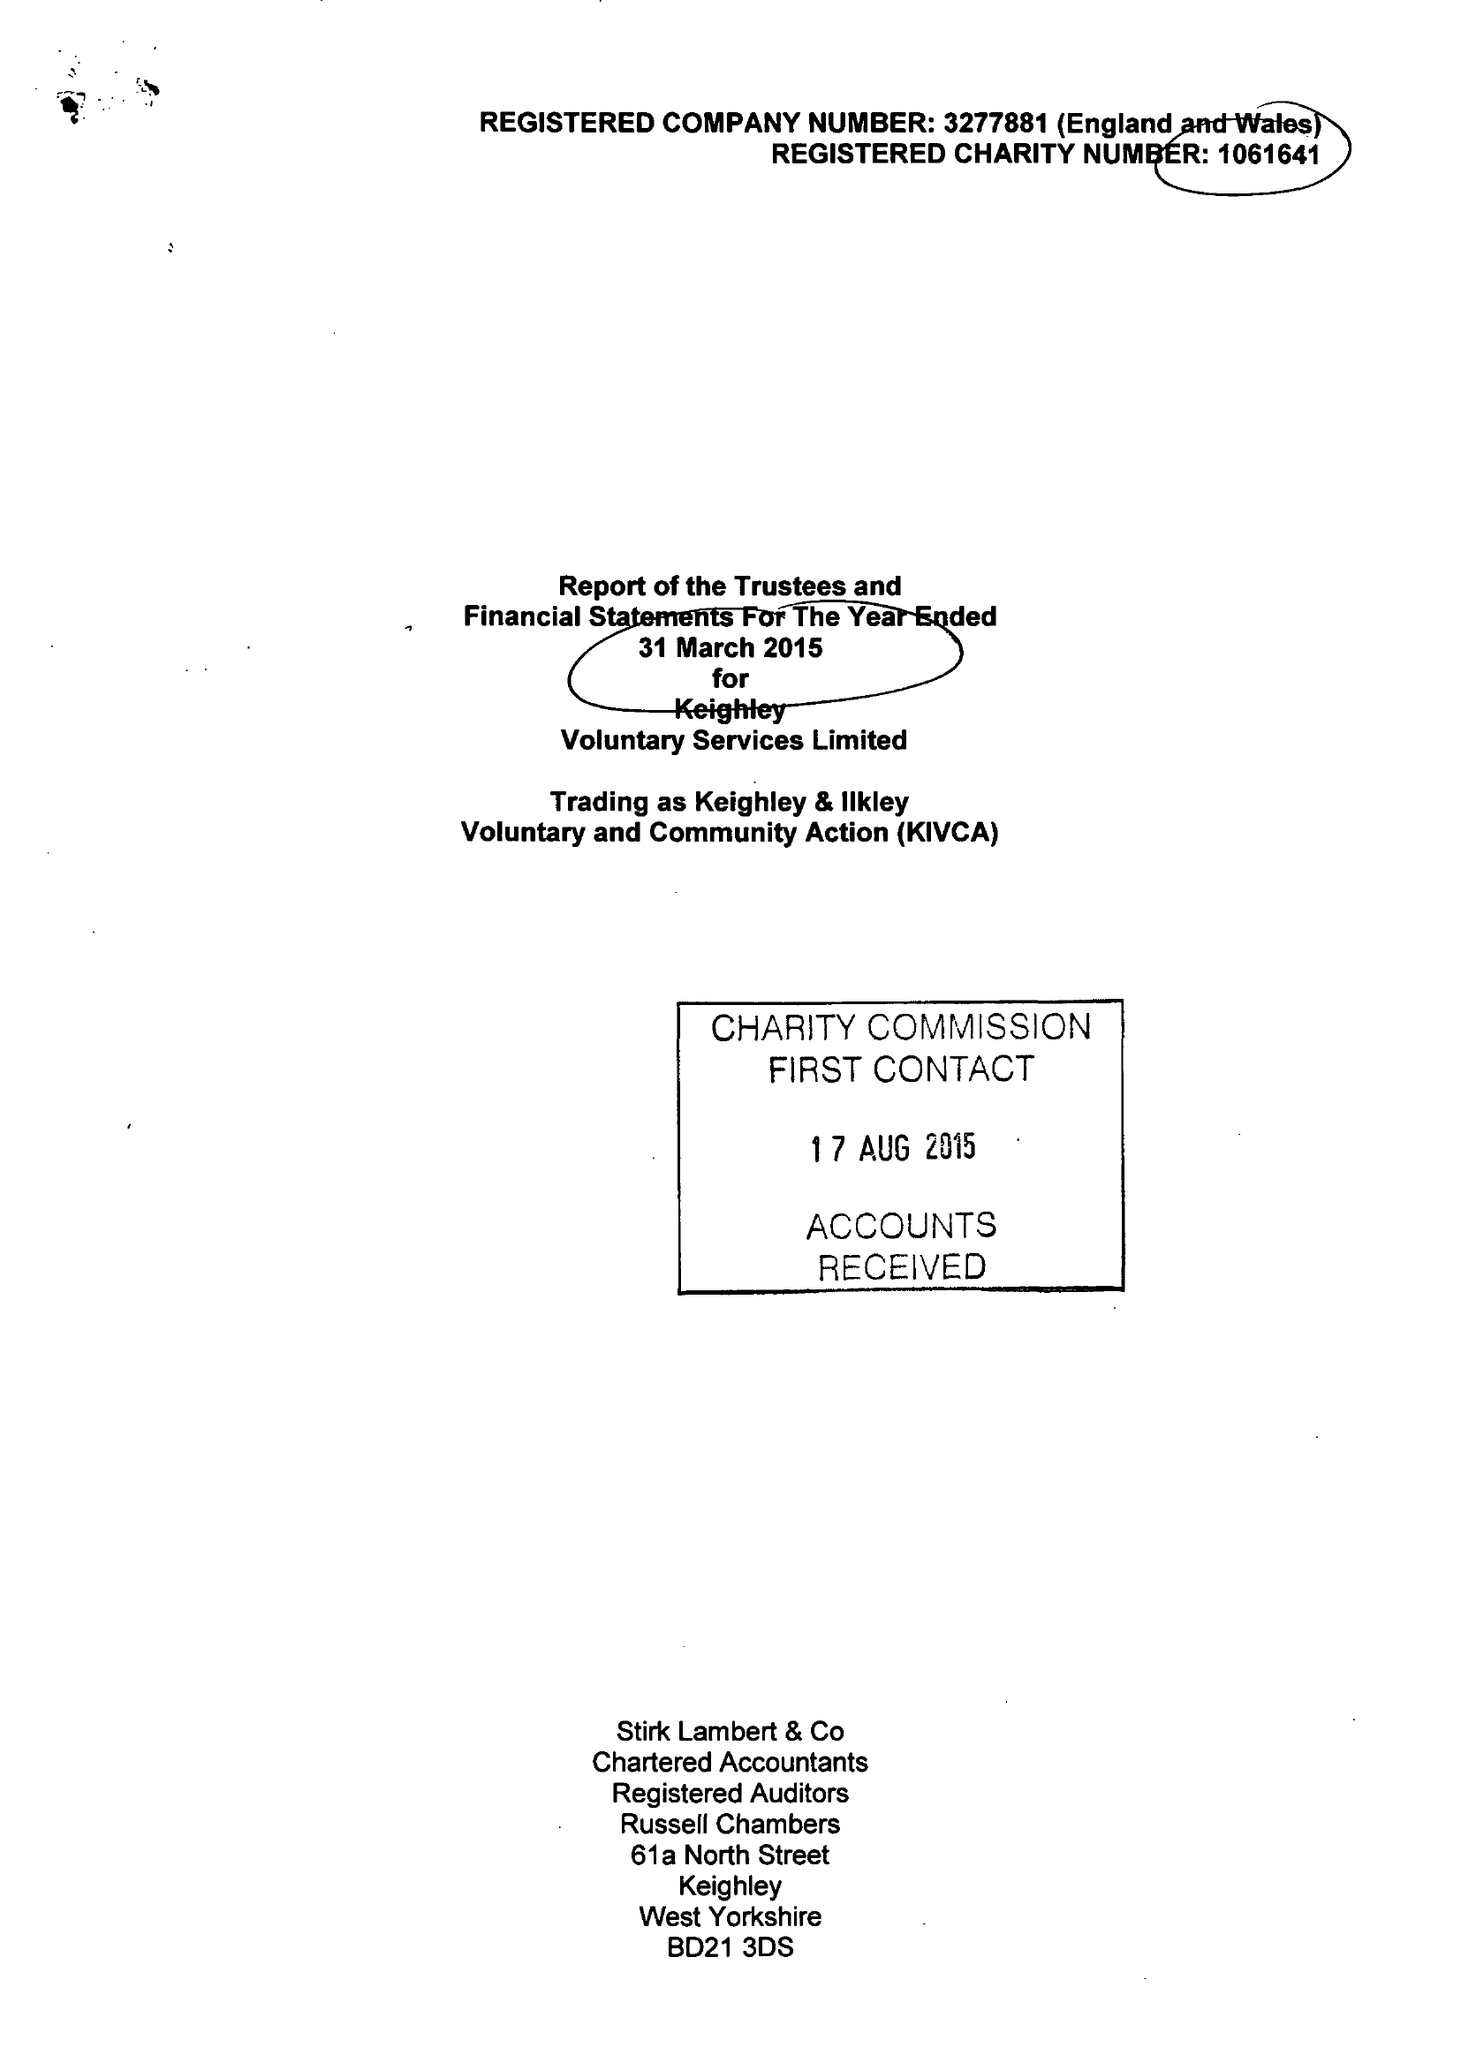What is the value for the income_annually_in_british_pounds?
Answer the question using a single word or phrase. 880152.00 